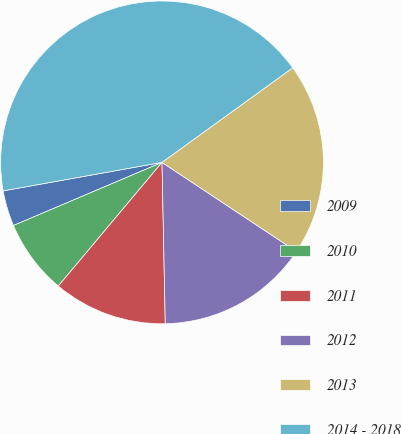<chart> <loc_0><loc_0><loc_500><loc_500><pie_chart><fcel>2009<fcel>2010<fcel>2011<fcel>2012<fcel>2013<fcel>2014 - 2018<nl><fcel>3.57%<fcel>7.5%<fcel>11.43%<fcel>15.36%<fcel>19.29%<fcel>42.86%<nl></chart> 